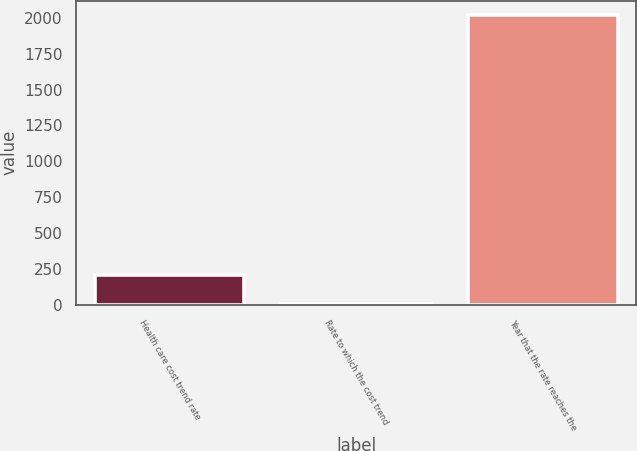<chart> <loc_0><loc_0><loc_500><loc_500><bar_chart><fcel>Health care cost trend rate<fcel>Rate to which the cost trend<fcel>Year that the rate reaches the<nl><fcel>205.84<fcel>4.49<fcel>2018<nl></chart> 